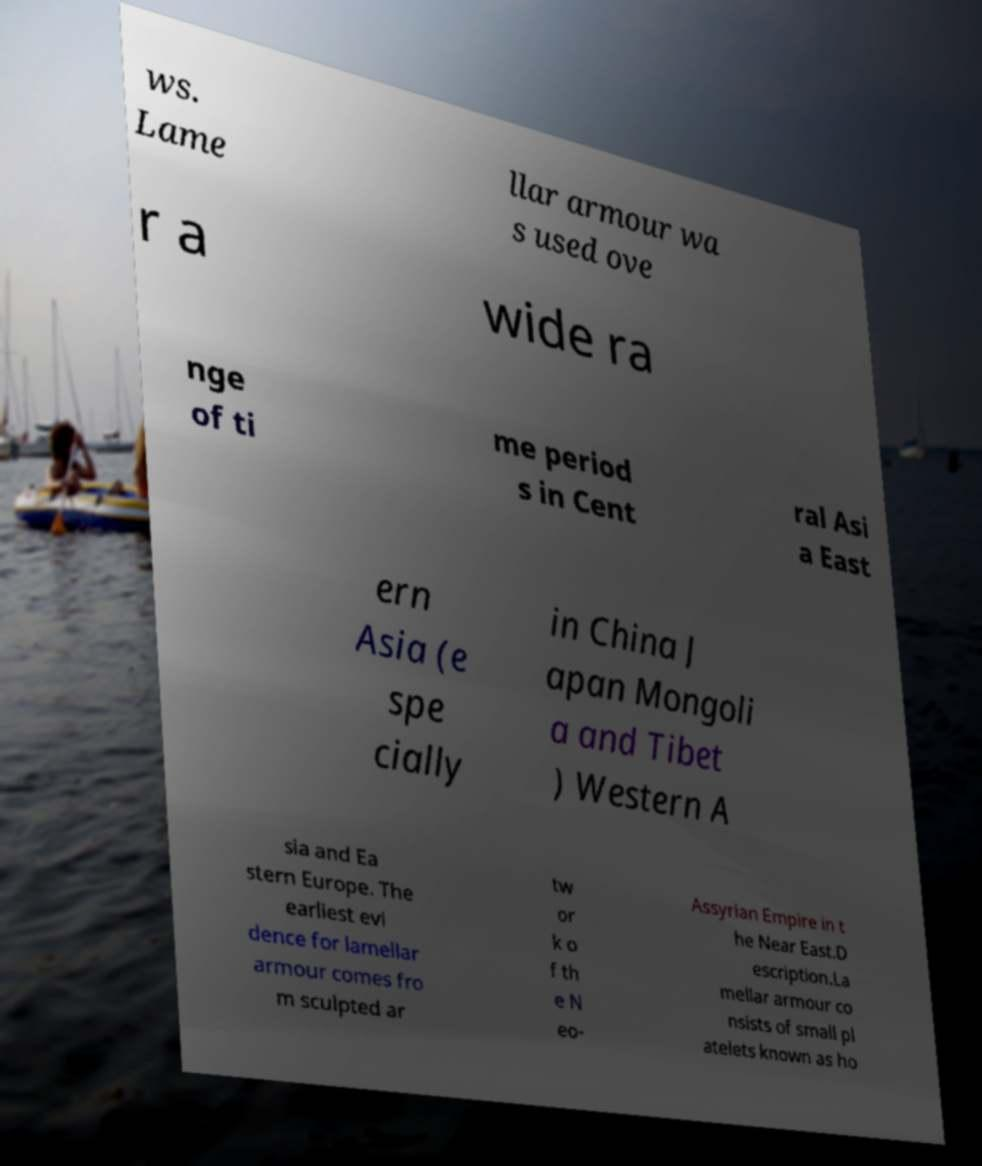Please identify and transcribe the text found in this image. ws. Lame llar armour wa s used ove r a wide ra nge of ti me period s in Cent ral Asi a East ern Asia (e spe cially in China J apan Mongoli a and Tibet ) Western A sia and Ea stern Europe. The earliest evi dence for lamellar armour comes fro m sculpted ar tw or k o f th e N eo- Assyrian Empire in t he Near East.D escription.La mellar armour co nsists of small pl atelets known as ho 